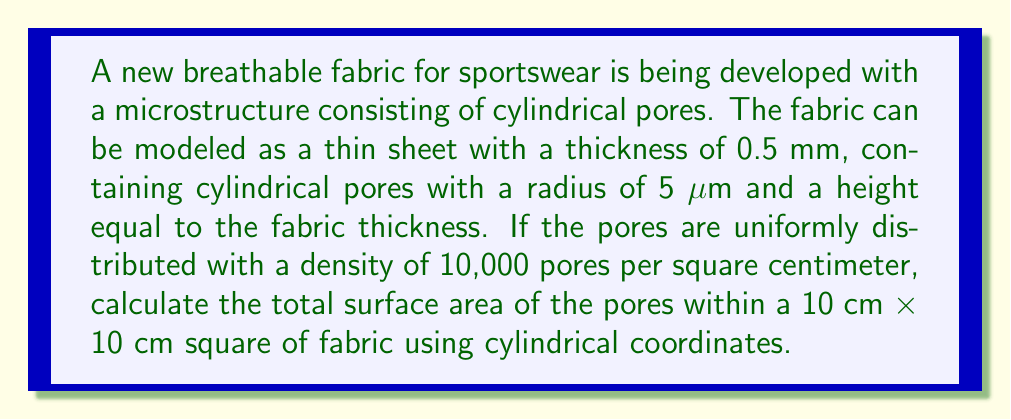Help me with this question. To solve this problem, we'll follow these steps:

1) First, let's calculate the surface area of a single cylindrical pore:

   The surface area of a cylinder consists of two parts:
   a) The lateral surface area: $2\pi r h$
   b) The top and bottom circular areas: $2\pi r^2$

   Where $r$ is the radius and $h$ is the height.

   $$ SA_{pore} = 2\pi r h + 2\pi r^2 $$

   Given: $r = 5 \text{ μm} = 5 \times 10^{-6} \text{ m}$, $h = 0.5 \text{ mm} = 5 \times 10^{-4} \text{ m}$

   $$ SA_{pore} = 2\pi (5 \times 10^{-6})(5 \times 10^{-4}) + 2\pi (5 \times 10^{-6})^2 $$
   $$ = 15.7080 \times 10^{-9} + 0.1571 \times 10^{-9} = 15.8651 \times 10^{-9} \text{ m}^2 $$

2) Now, let's calculate the number of pores in a 10 cm × 10 cm square:

   Given: 10,000 pores per square centimeter
   Area: 10 cm × 10 cm = 100 cm²

   Number of pores = 10,000 × 100 = 1,000,000 pores

3) Finally, we can calculate the total surface area of all pores:

   $$ SA_{total} = 1,000,000 \times 15.8651 \times 10^{-9} = 0.0158651 \text{ m}^2 $$

In cylindrical coordinates, we could express the surface of each pore as:

$$ r = 5 \times 10^{-6}, \quad 0 \leq \theta \leq 2\pi, \quad 0 \leq z \leq 5 \times 10^{-4} $$

The surface area element in cylindrical coordinates is:

$$ dS = r \, d\theta \, dz $$

Integrating this over the surface of the cylinder gives us the lateral surface area:

$$ SA_{lateral} = \int_0^{2\pi} \int_0^h r \, dz \, d\theta = 2\pi r h $$

Adding the areas of the top and bottom circles gives us the total surface area of a single pore, which we then multiply by the number of pores to get the total surface area.
Answer: The total surface area of the pores within a 10 cm × 10 cm square of fabric is approximately 0.0158651 m² or 158.651 cm². 